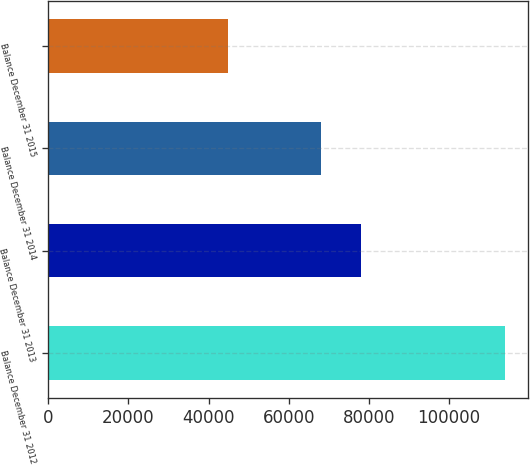Convert chart to OTSL. <chart><loc_0><loc_0><loc_500><loc_500><bar_chart><fcel>Balance December 31 2012<fcel>Balance December 31 2013<fcel>Balance December 31 2014<fcel>Balance December 31 2015<nl><fcel>114008<fcel>78053<fcel>68141<fcel>44748<nl></chart> 